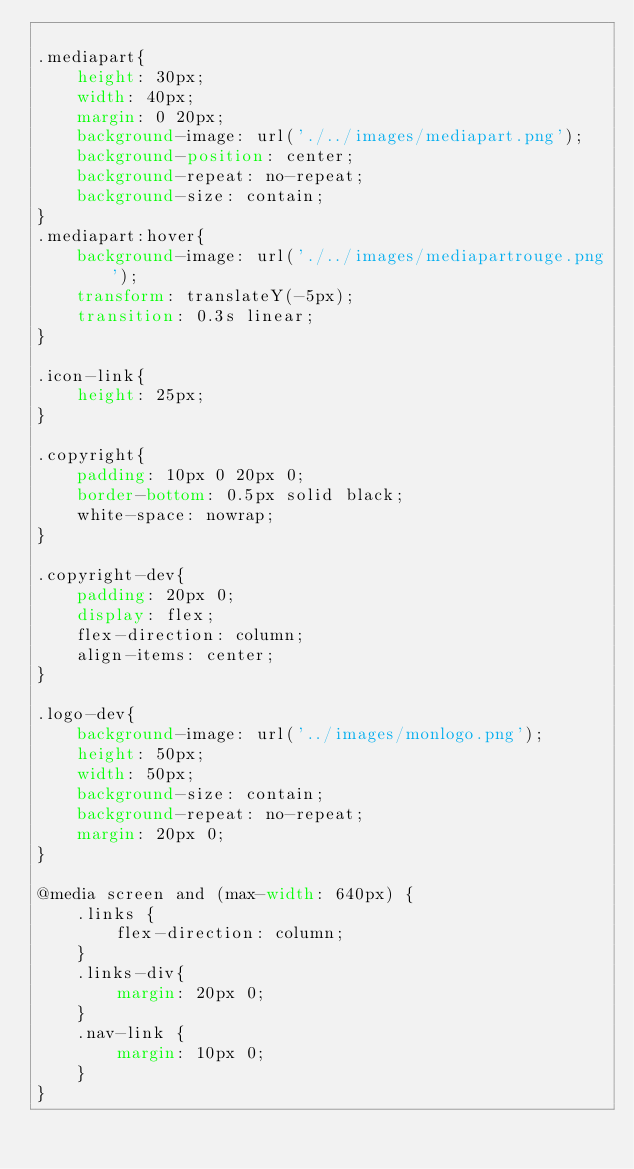<code> <loc_0><loc_0><loc_500><loc_500><_CSS_>
.mediapart{
    height: 30px;
    width: 40px;
    margin: 0 20px;
    background-image: url('./../images/mediapart.png');
    background-position: center;
    background-repeat: no-repeat;
    background-size: contain;
}
.mediapart:hover{
    background-image: url('./../images/mediapartrouge.png');
    transform: translateY(-5px);
    transition: 0.3s linear;
}

.icon-link{
    height: 25px;
}

.copyright{
    padding: 10px 0 20px 0;
    border-bottom: 0.5px solid black;
    white-space: nowrap;
}

.copyright-dev{
    padding: 20px 0;
    display: flex;
    flex-direction: column;
    align-items: center;
}

.logo-dev{
    background-image: url('../images/monlogo.png');
    height: 50px;
    width: 50px;
    background-size: contain;
    background-repeat: no-repeat;
    margin: 20px 0;
}

@media screen and (max-width: 640px) {
    .links {
        flex-direction: column;
    }
    .links-div{
        margin: 20px 0;
    }
    .nav-link {
        margin: 10px 0;
    }
}</code> 